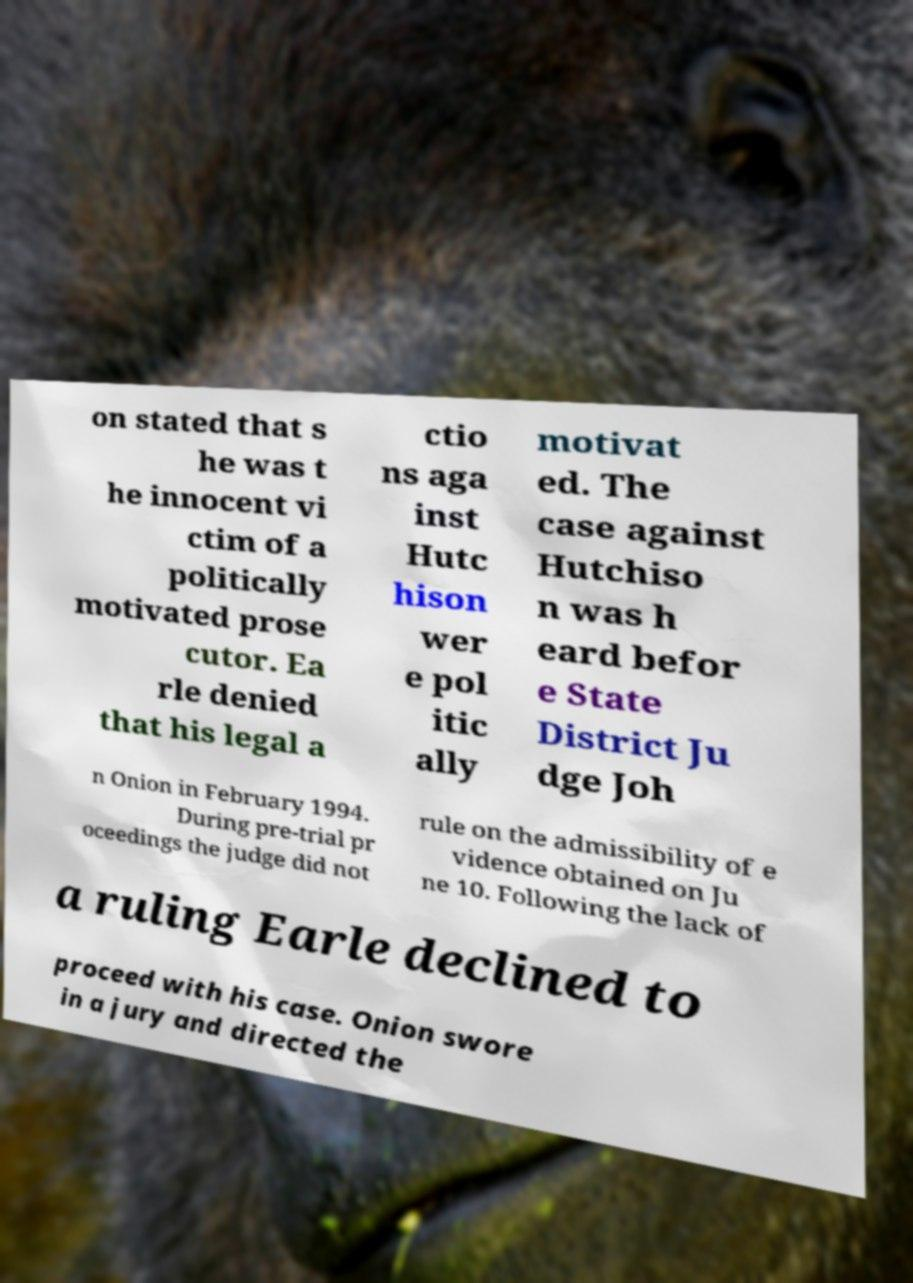Please read and relay the text visible in this image. What does it say? on stated that s he was t he innocent vi ctim of a politically motivated prose cutor. Ea rle denied that his legal a ctio ns aga inst Hutc hison wer e pol itic ally motivat ed. The case against Hutchiso n was h eard befor e State District Ju dge Joh n Onion in February 1994. During pre-trial pr oceedings the judge did not rule on the admissibility of e vidence obtained on Ju ne 10. Following the lack of a ruling Earle declined to proceed with his case. Onion swore in a jury and directed the 